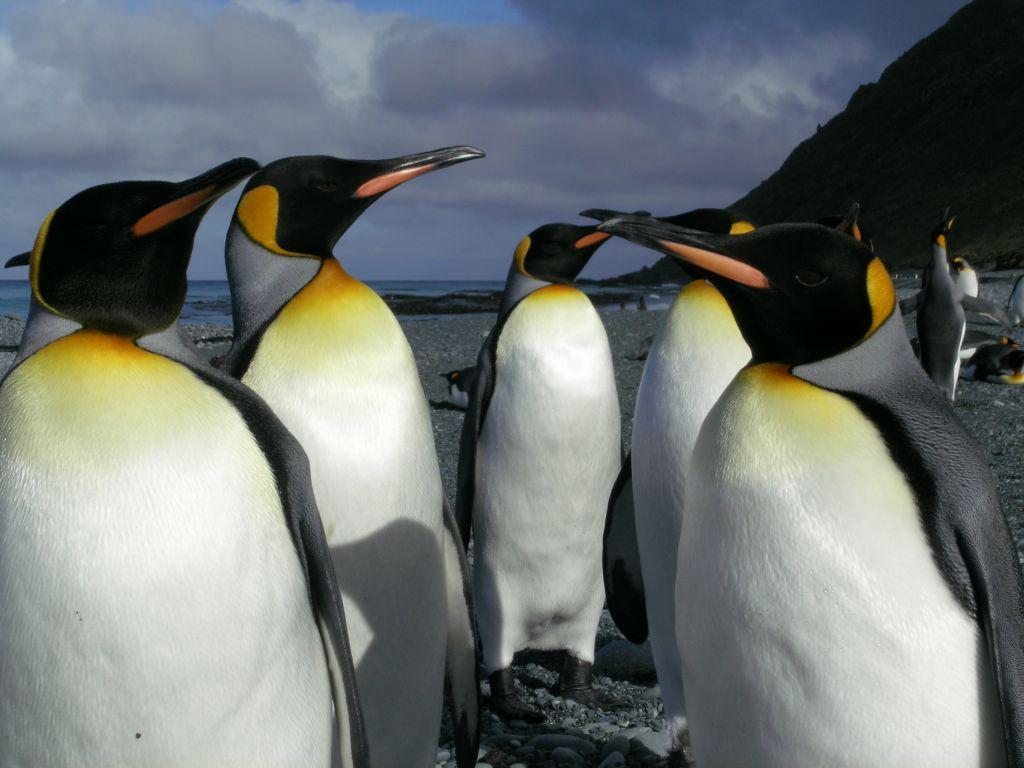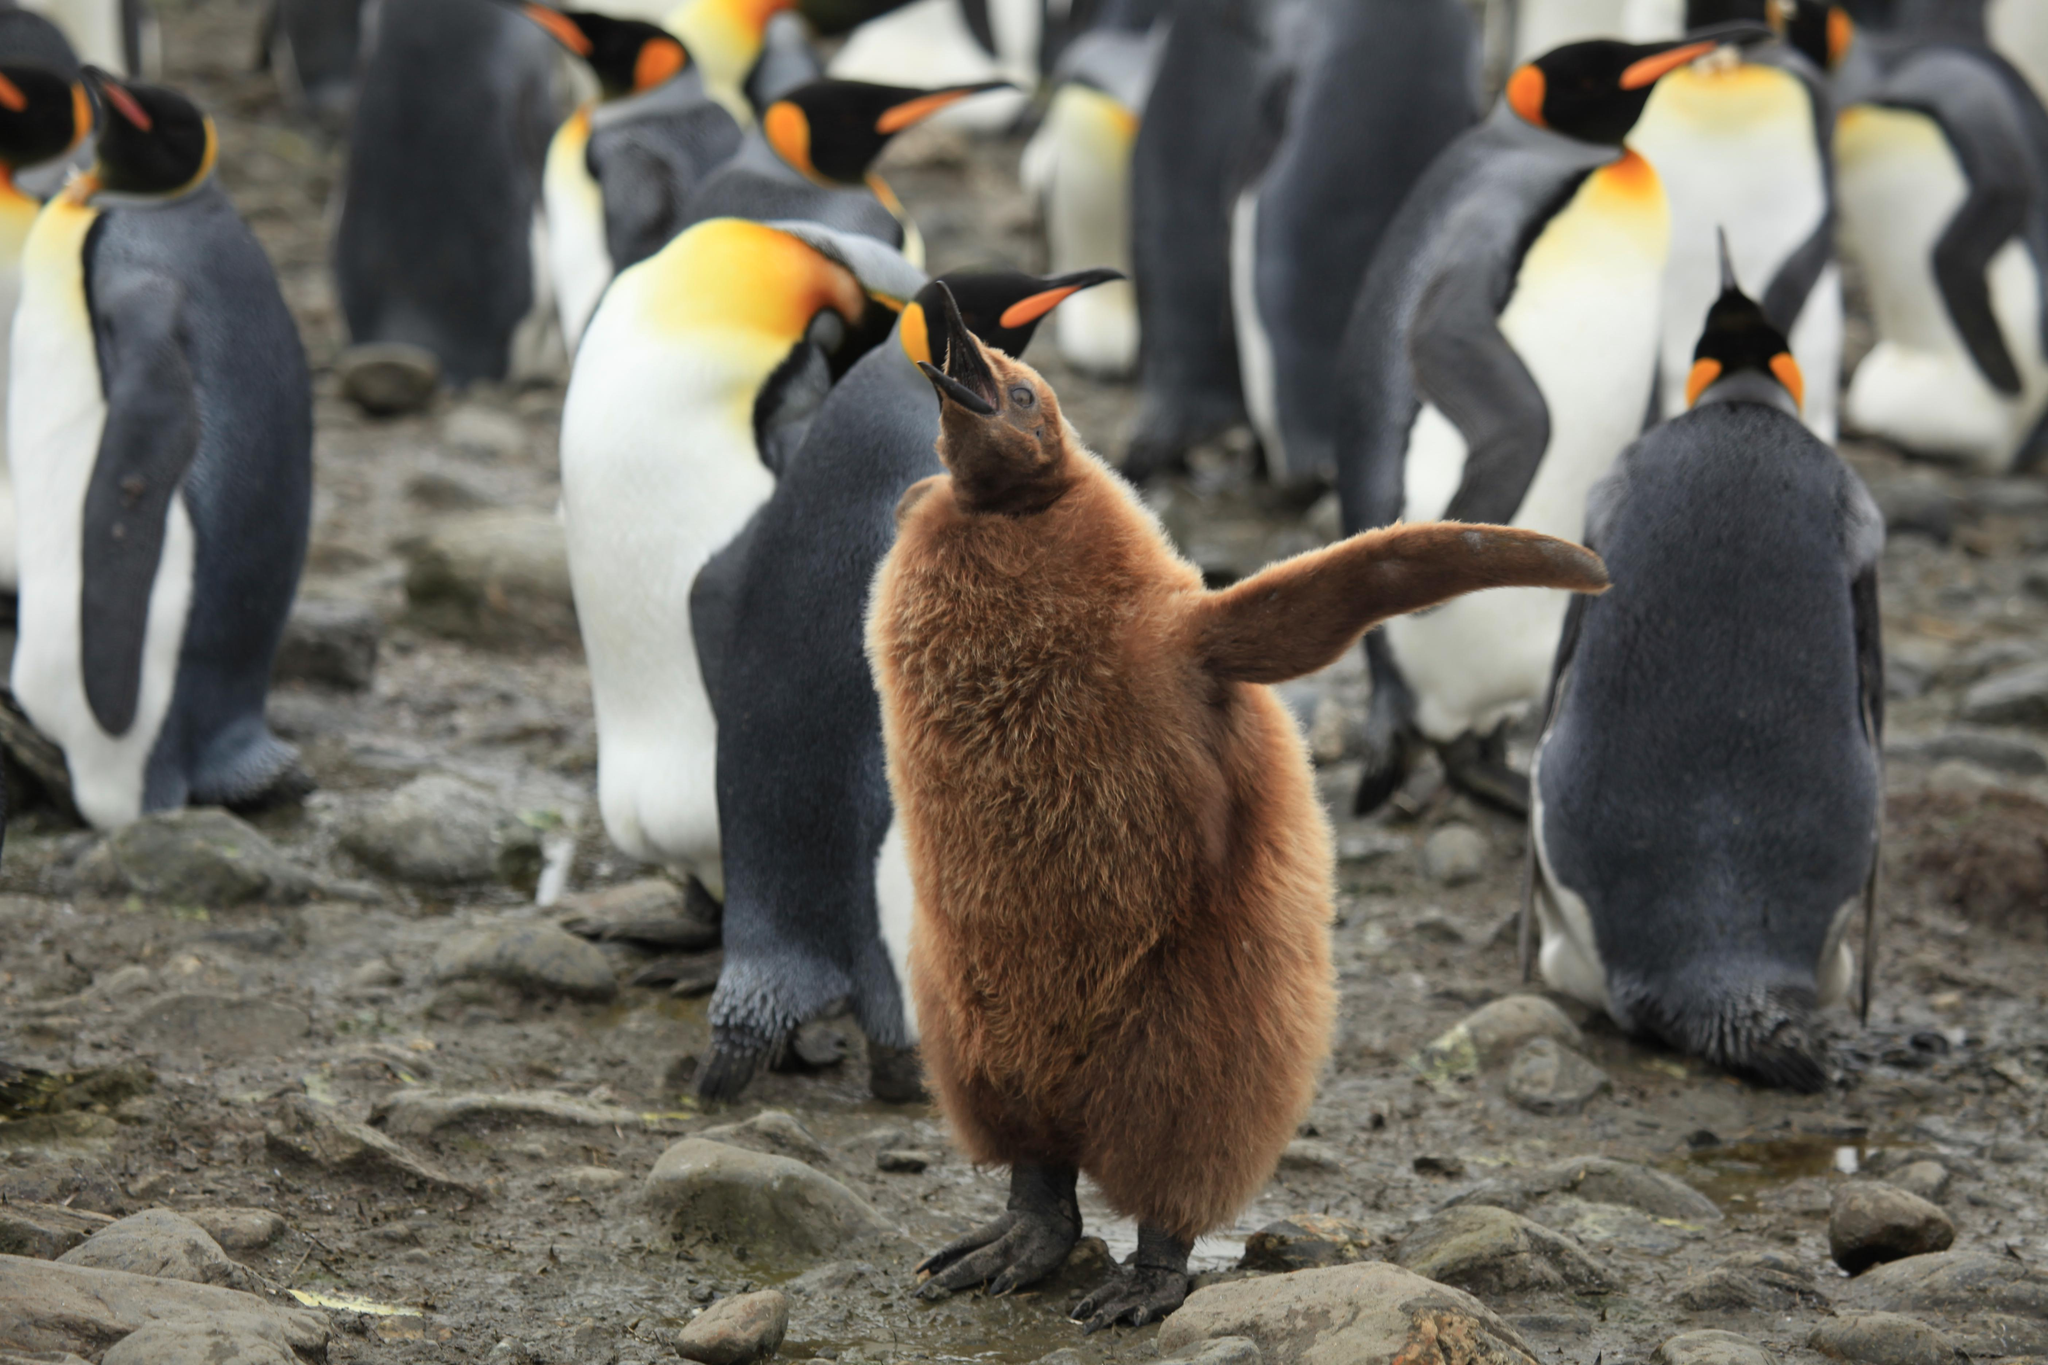The first image is the image on the left, the second image is the image on the right. Analyze the images presented: Is the assertion "There are four penguins" valid? Answer yes or no. No. 